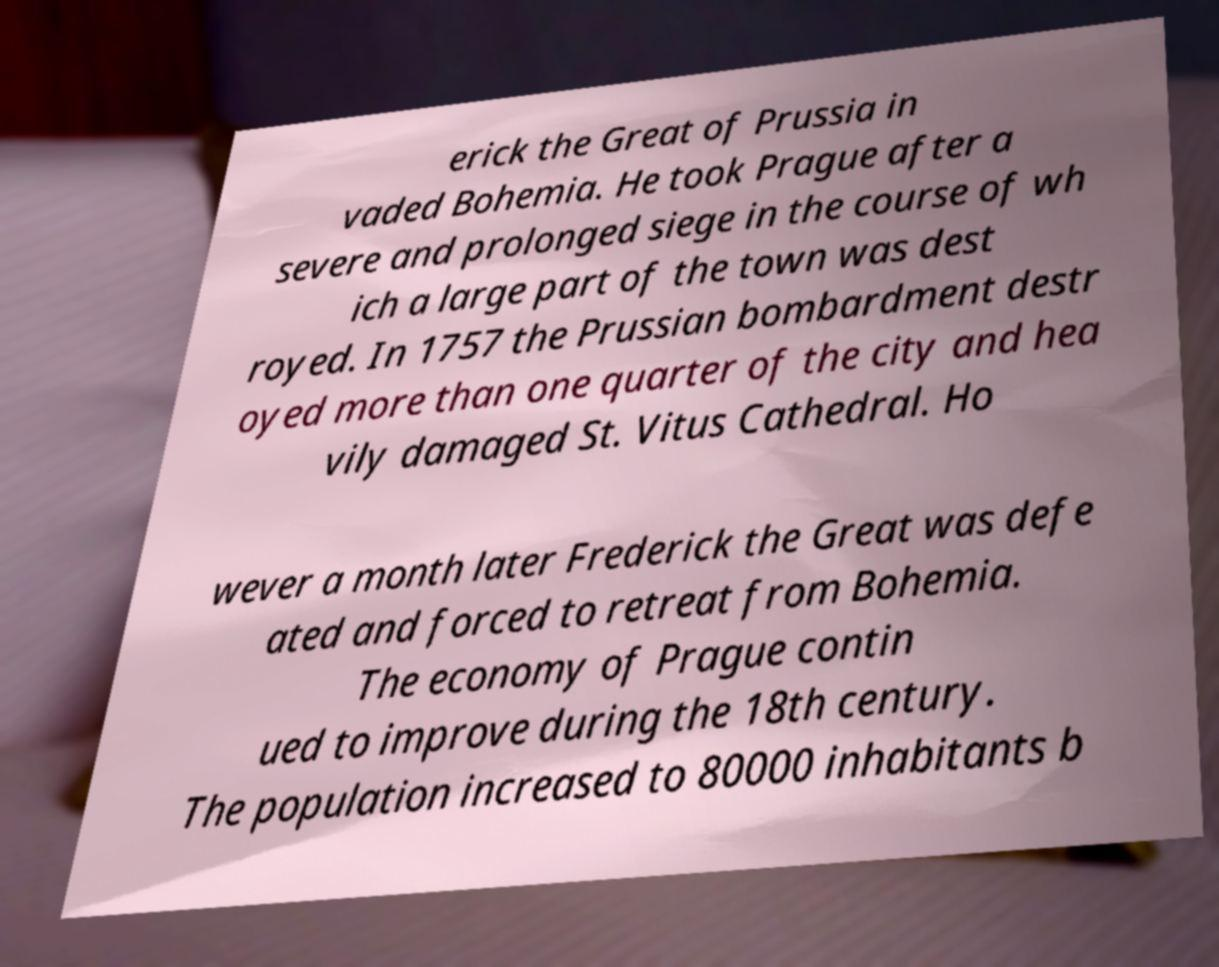Can you accurately transcribe the text from the provided image for me? erick the Great of Prussia in vaded Bohemia. He took Prague after a severe and prolonged siege in the course of wh ich a large part of the town was dest royed. In 1757 the Prussian bombardment destr oyed more than one quarter of the city and hea vily damaged St. Vitus Cathedral. Ho wever a month later Frederick the Great was defe ated and forced to retreat from Bohemia. The economy of Prague contin ued to improve during the 18th century. The population increased to 80000 inhabitants b 